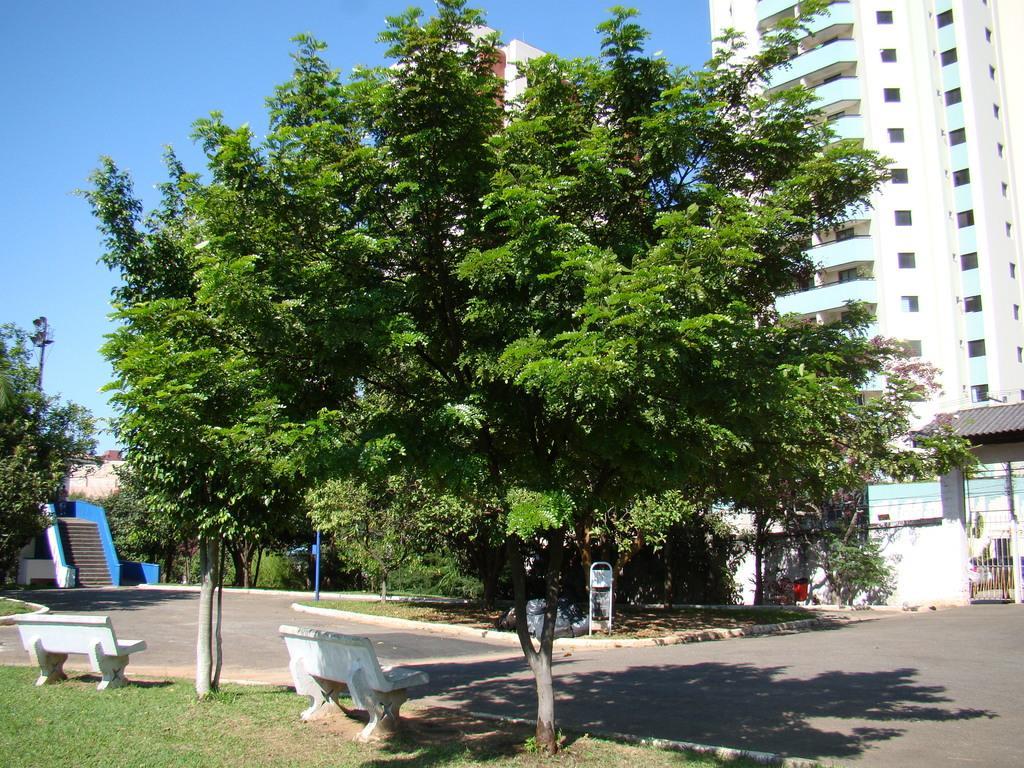How would you summarize this image in a sentence or two? In this image, we can see trees, buildings, stairs, benches, poles and we can see a gate. At the bottom, there is a road and at the top, there is sky. 